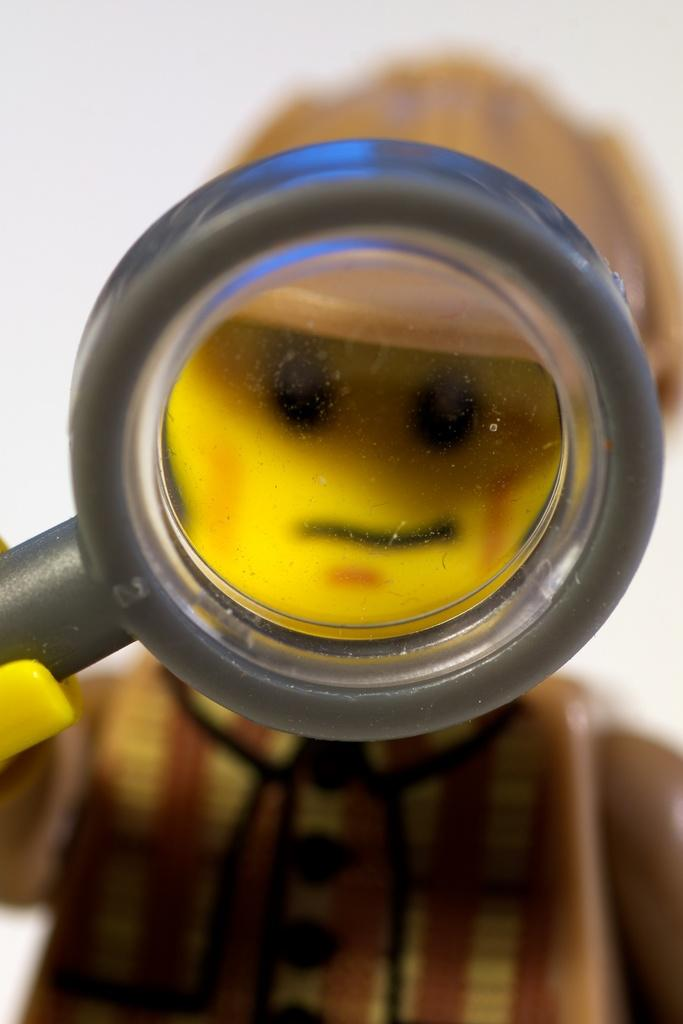What is the main subject of the image? There is a doll in the image. What is the doll holding in its hand? The doll is holding a magnifying glass in its hand. What type of dinosaurs can be seen in the image? There are no dinosaurs present in the image; it features a doll holding a magnifying glass. What arithmetic problem is the doll trying to solve in the image? There is no arithmetic problem depicted in the image; the doll is simply holding a magnifying glass. 